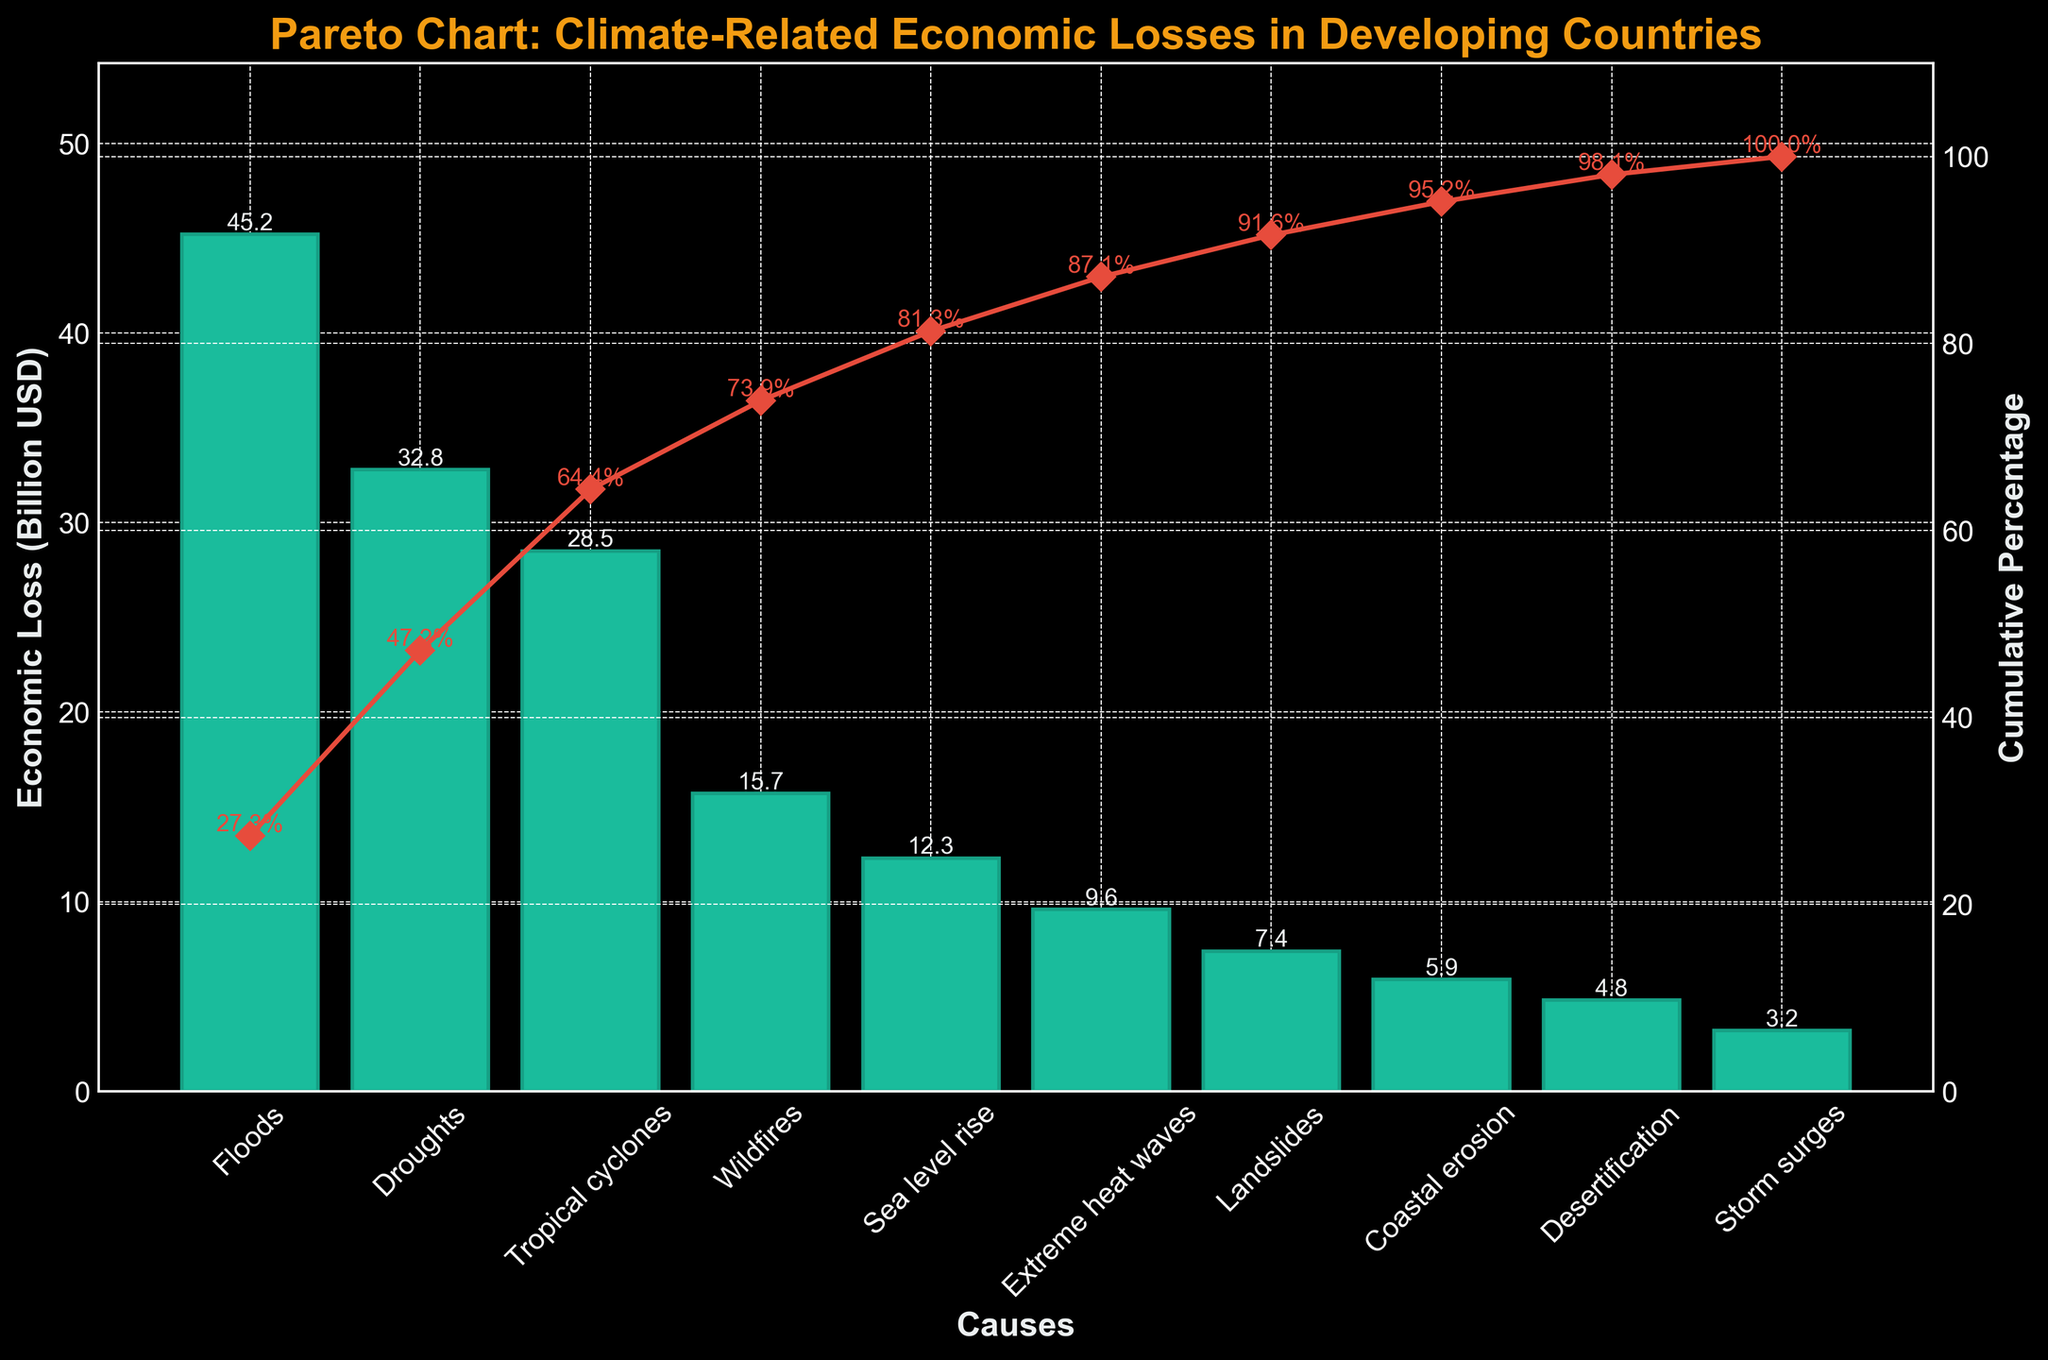Which cause resulted in the highest economic loss? The highest bar on the chart represents the cause with the highest economic loss. This is seen by the bar labeled 'Floods'.
Answer: Floods What is the cumulative percentage for the top two causes of economic loss? The cumulative percentage line indicates the sum of the percentages of losses contributed by the top causes. For Floods and Droughts, we check the cumulative percentage value at the second data point.
Answer: 46.0% How many causes have an economic loss greater than 20 billion USD? Looking at the heights of the bars, count the ones that reach above the 20 billion USD mark. There are three of these: Floods, Droughts, and Tropical cyclones.
Answer: 3 Which cause has the smallest economic loss? The shortest bar represents the cause with the smallest economic loss. This is the bar labeled 'Storm surges'.
Answer: Storm surges By how much does the economic loss from Wildfires exceed that from Coastal erosion? Subtract the economic loss value of Coastal erosion from that of Wildfires, which are 15.7 and 5.9 billion USD respectively. 15.7 - 5.9 = 9.8 billion USD.
Answer: 9.8 billion USD What percentage of the total economic loss do the top three causes contribute? Sum the losses of Floods, Droughts, and Tropical cyclones (45.2 + 32.8 + 28.5 = 106.5 billion USD). Divide by the total economic loss and multiply by 100. The percentage can also be seen by looking at the cumulative percentage at the third data point: 70.8%.
Answer: 70.8% Compare the economic loss from Extreme heat waves and Landslides. Which one is higher? Observe the heights of the bars for Extreme heat waves and Landslides. The bar for Extreme heat waves reaches 9.6 billion USD, and the bar for Landslides reaches 7.4 billion USD.
Answer: Extreme heat waves What is the economic loss for Coastal erosion in billion USD? Directly read the height of the bar representing Coastal erosion.
Answer: 5.9 billion USD Which causes combined account for approximately 90% of the total economic loss? Track the cumulative percentage line until it reaches close to 90%. Assess which causes add up to that point: Floods, Droughts, Tropical cyclones, Wildfires, and Sea level rise.
Answer: Floods, Droughts, Tropical cyclones, Wildfires, and Sea level rise What is the economic loss difference between the second highest and the fifth highest cause? Identify the second highest and fifth highest causes by the heights of their bars: Droughts (32.8 billion USD) and Sea level rise (12.3 billion USD). Subtract the losses: 32.8 - 12.3 = 20.5 billion USD.
Answer: 20.5 billion USD 